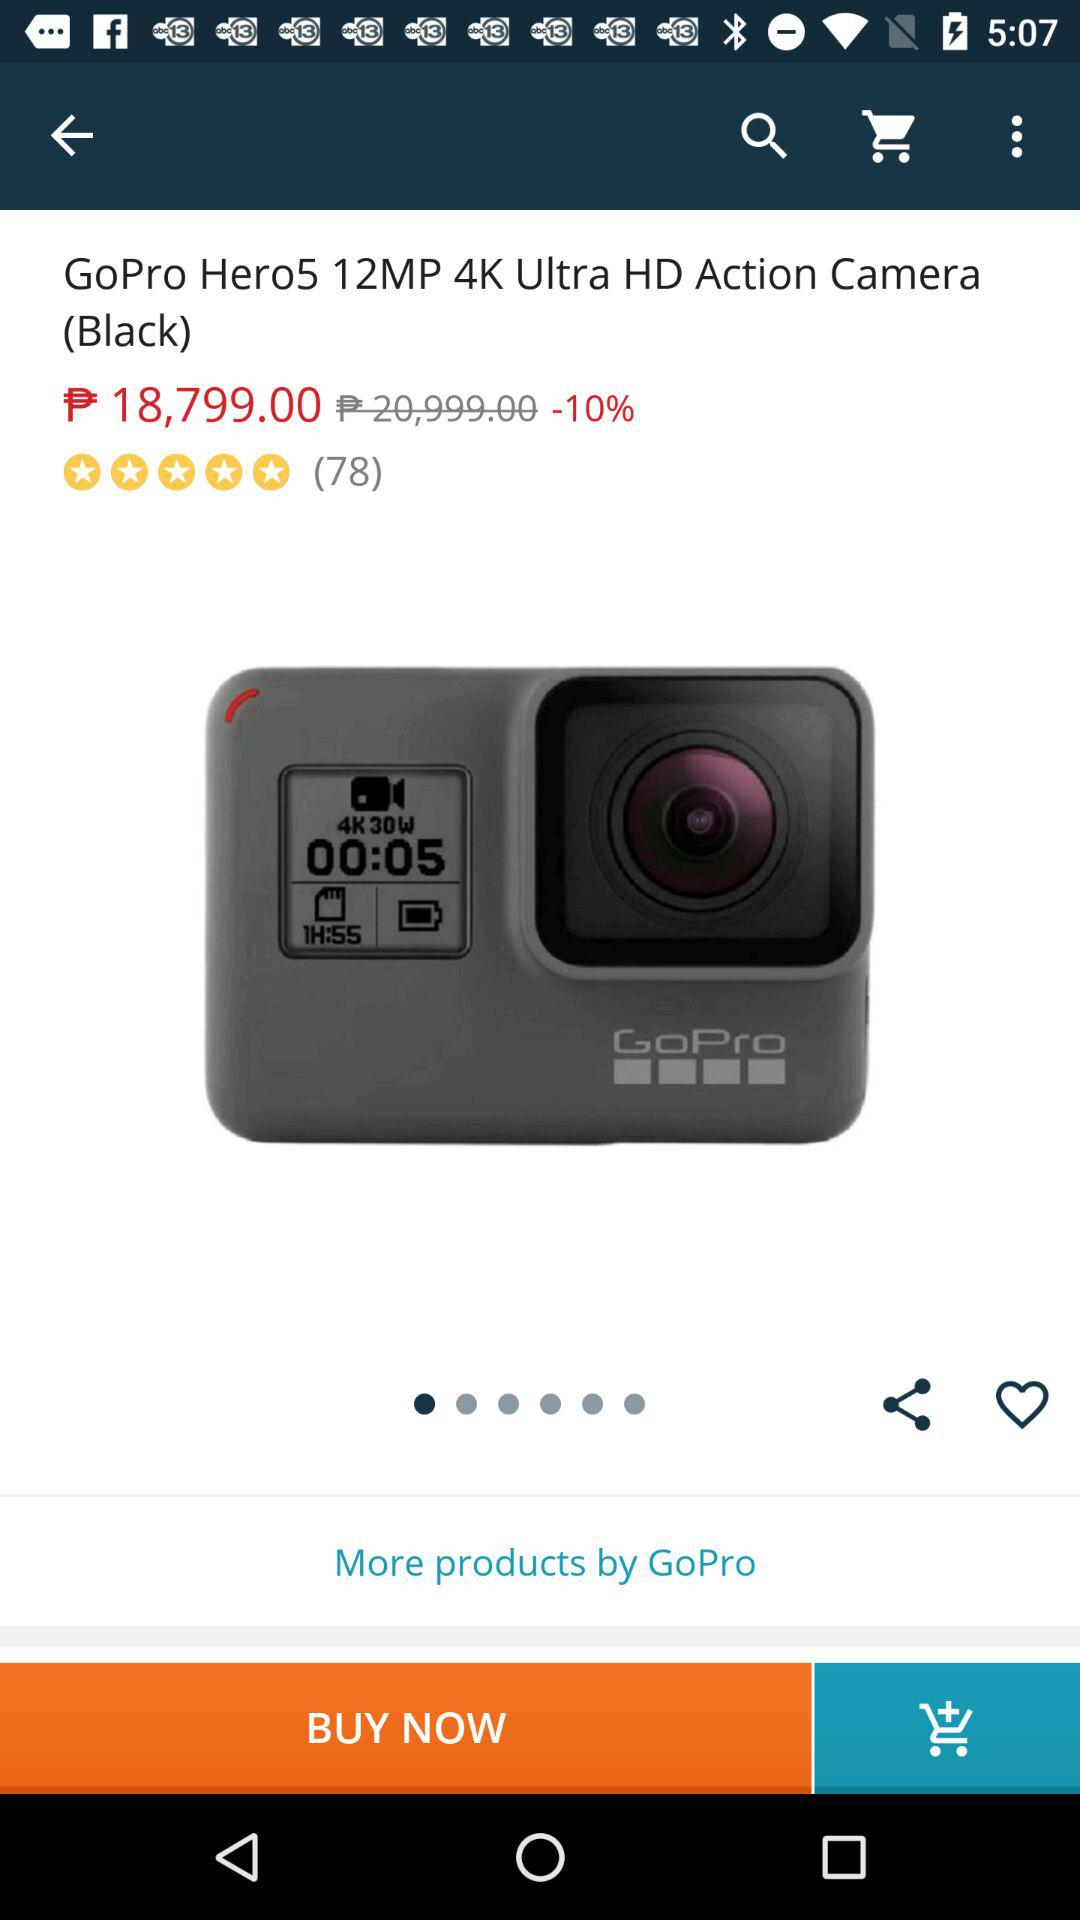What is the rating of the "GoPro Hero5 12MP 4K Ultra HD Action Camera (Black)"? The rating of the "GoPro Hero5 12MP 4K Ultra HD Action Camera (Black)" is 5 stars. 